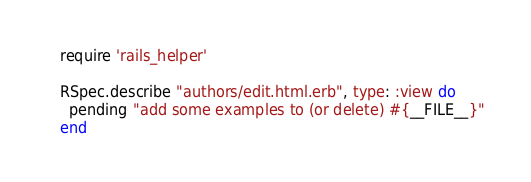<code> <loc_0><loc_0><loc_500><loc_500><_Ruby_>require 'rails_helper'

RSpec.describe "authors/edit.html.erb", type: :view do
  pending "add some examples to (or delete) #{__FILE__}"
end
</code> 